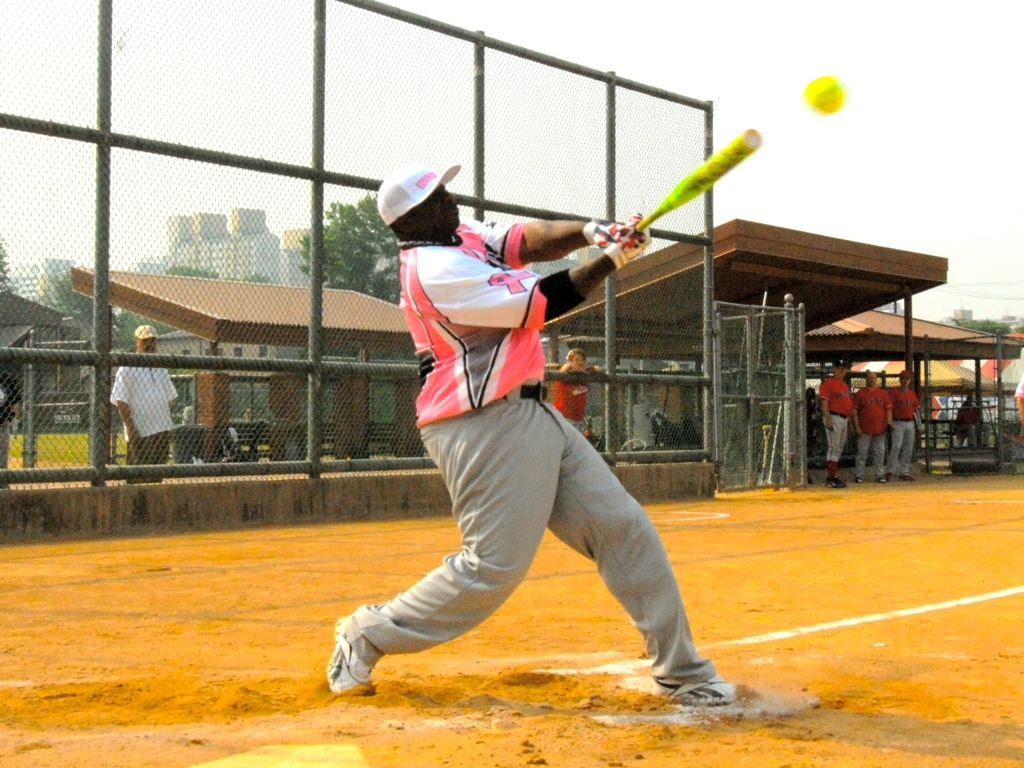What is the overall clarity of the image?
A. excellent
B. low
C. high
D. average The overall clarity of the image can be considered average (D). While the foreground, which features a player hitting a softball, is relatively clear, the background details are less distinct. This suggests the image captures action with a focus on the main subject, but some quality is lost possibly due to motion blur or camera focus settings. 